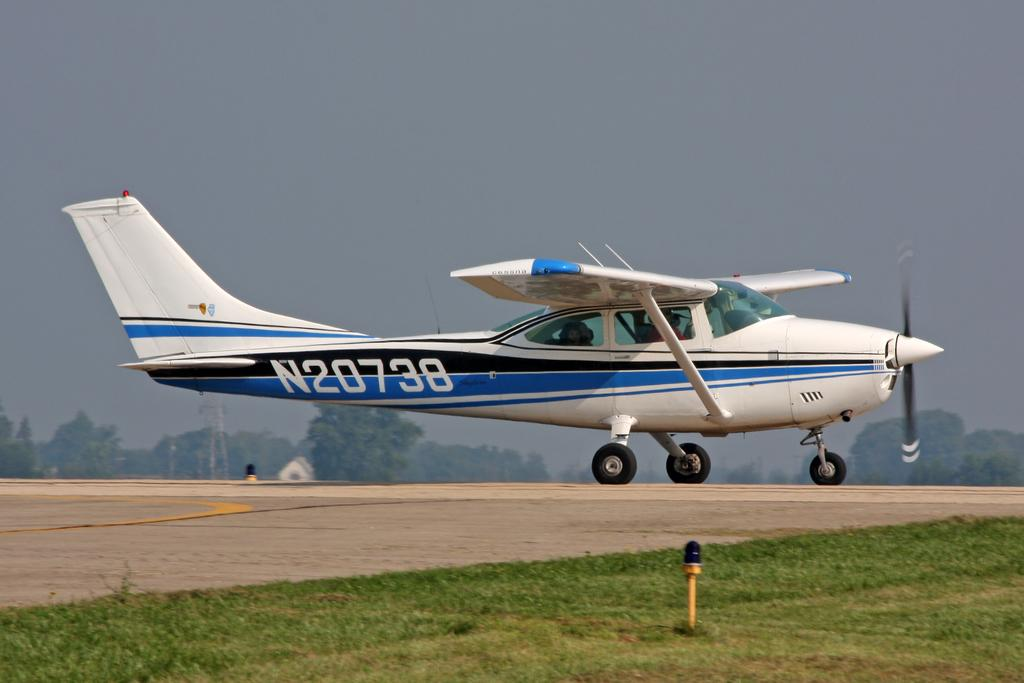<image>
Share a concise interpretation of the image provided. A small blue and white plan is landing on a runway with the tail number N20738.. 